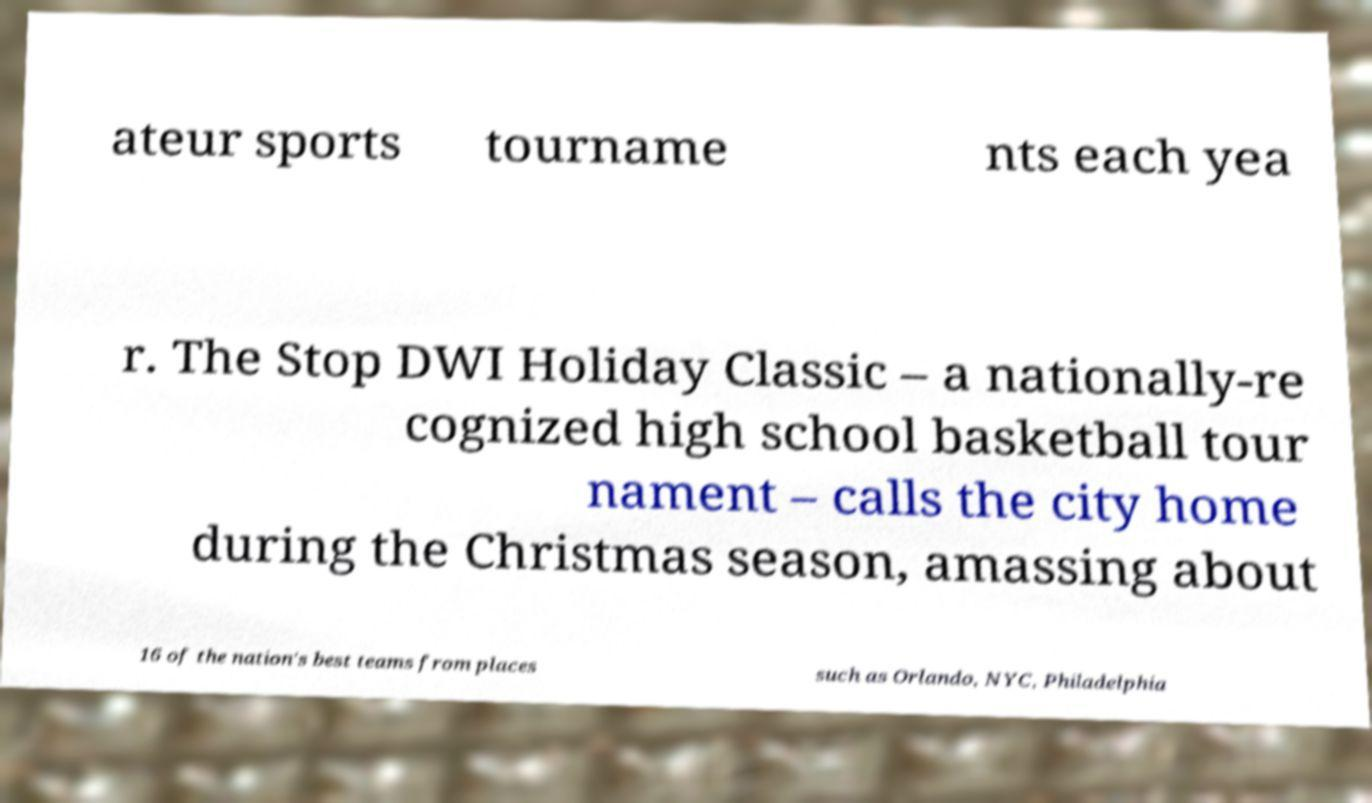Can you read and provide the text displayed in the image?This photo seems to have some interesting text. Can you extract and type it out for me? ateur sports tourname nts each yea r. The Stop DWI Holiday Classic – a nationally-re cognized high school basketball tour nament – calls the city home during the Christmas season, amassing about 16 of the nation's best teams from places such as Orlando, NYC, Philadelphia 